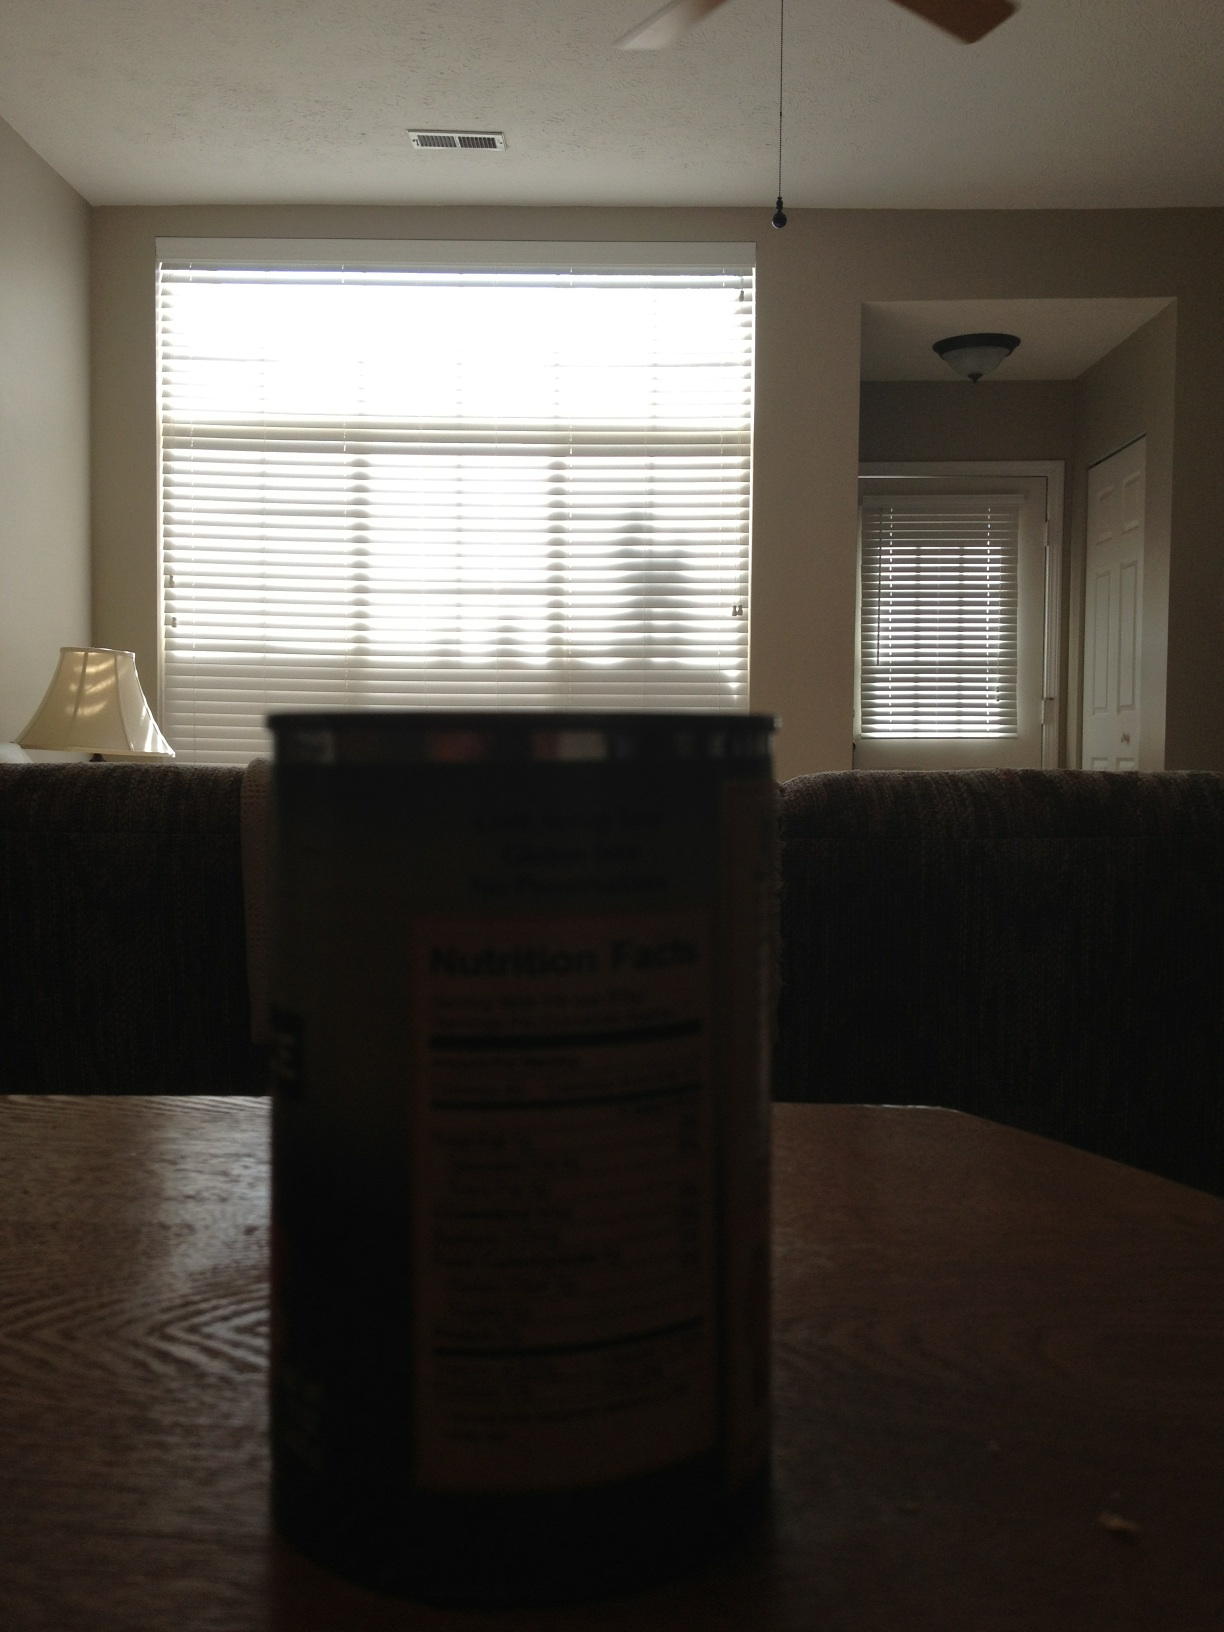Imagine this room is part of a story. What could be happening here? In a quiet suburban neighborhood, Kelly sits alone in her dim living room. The can of tomatoes on the table is a reminder of her late-night attempts at cooking—a new hobby she's picked up to fill the silence. The room feels still, as if holding its breath, waiting for the next chapter in her story. 